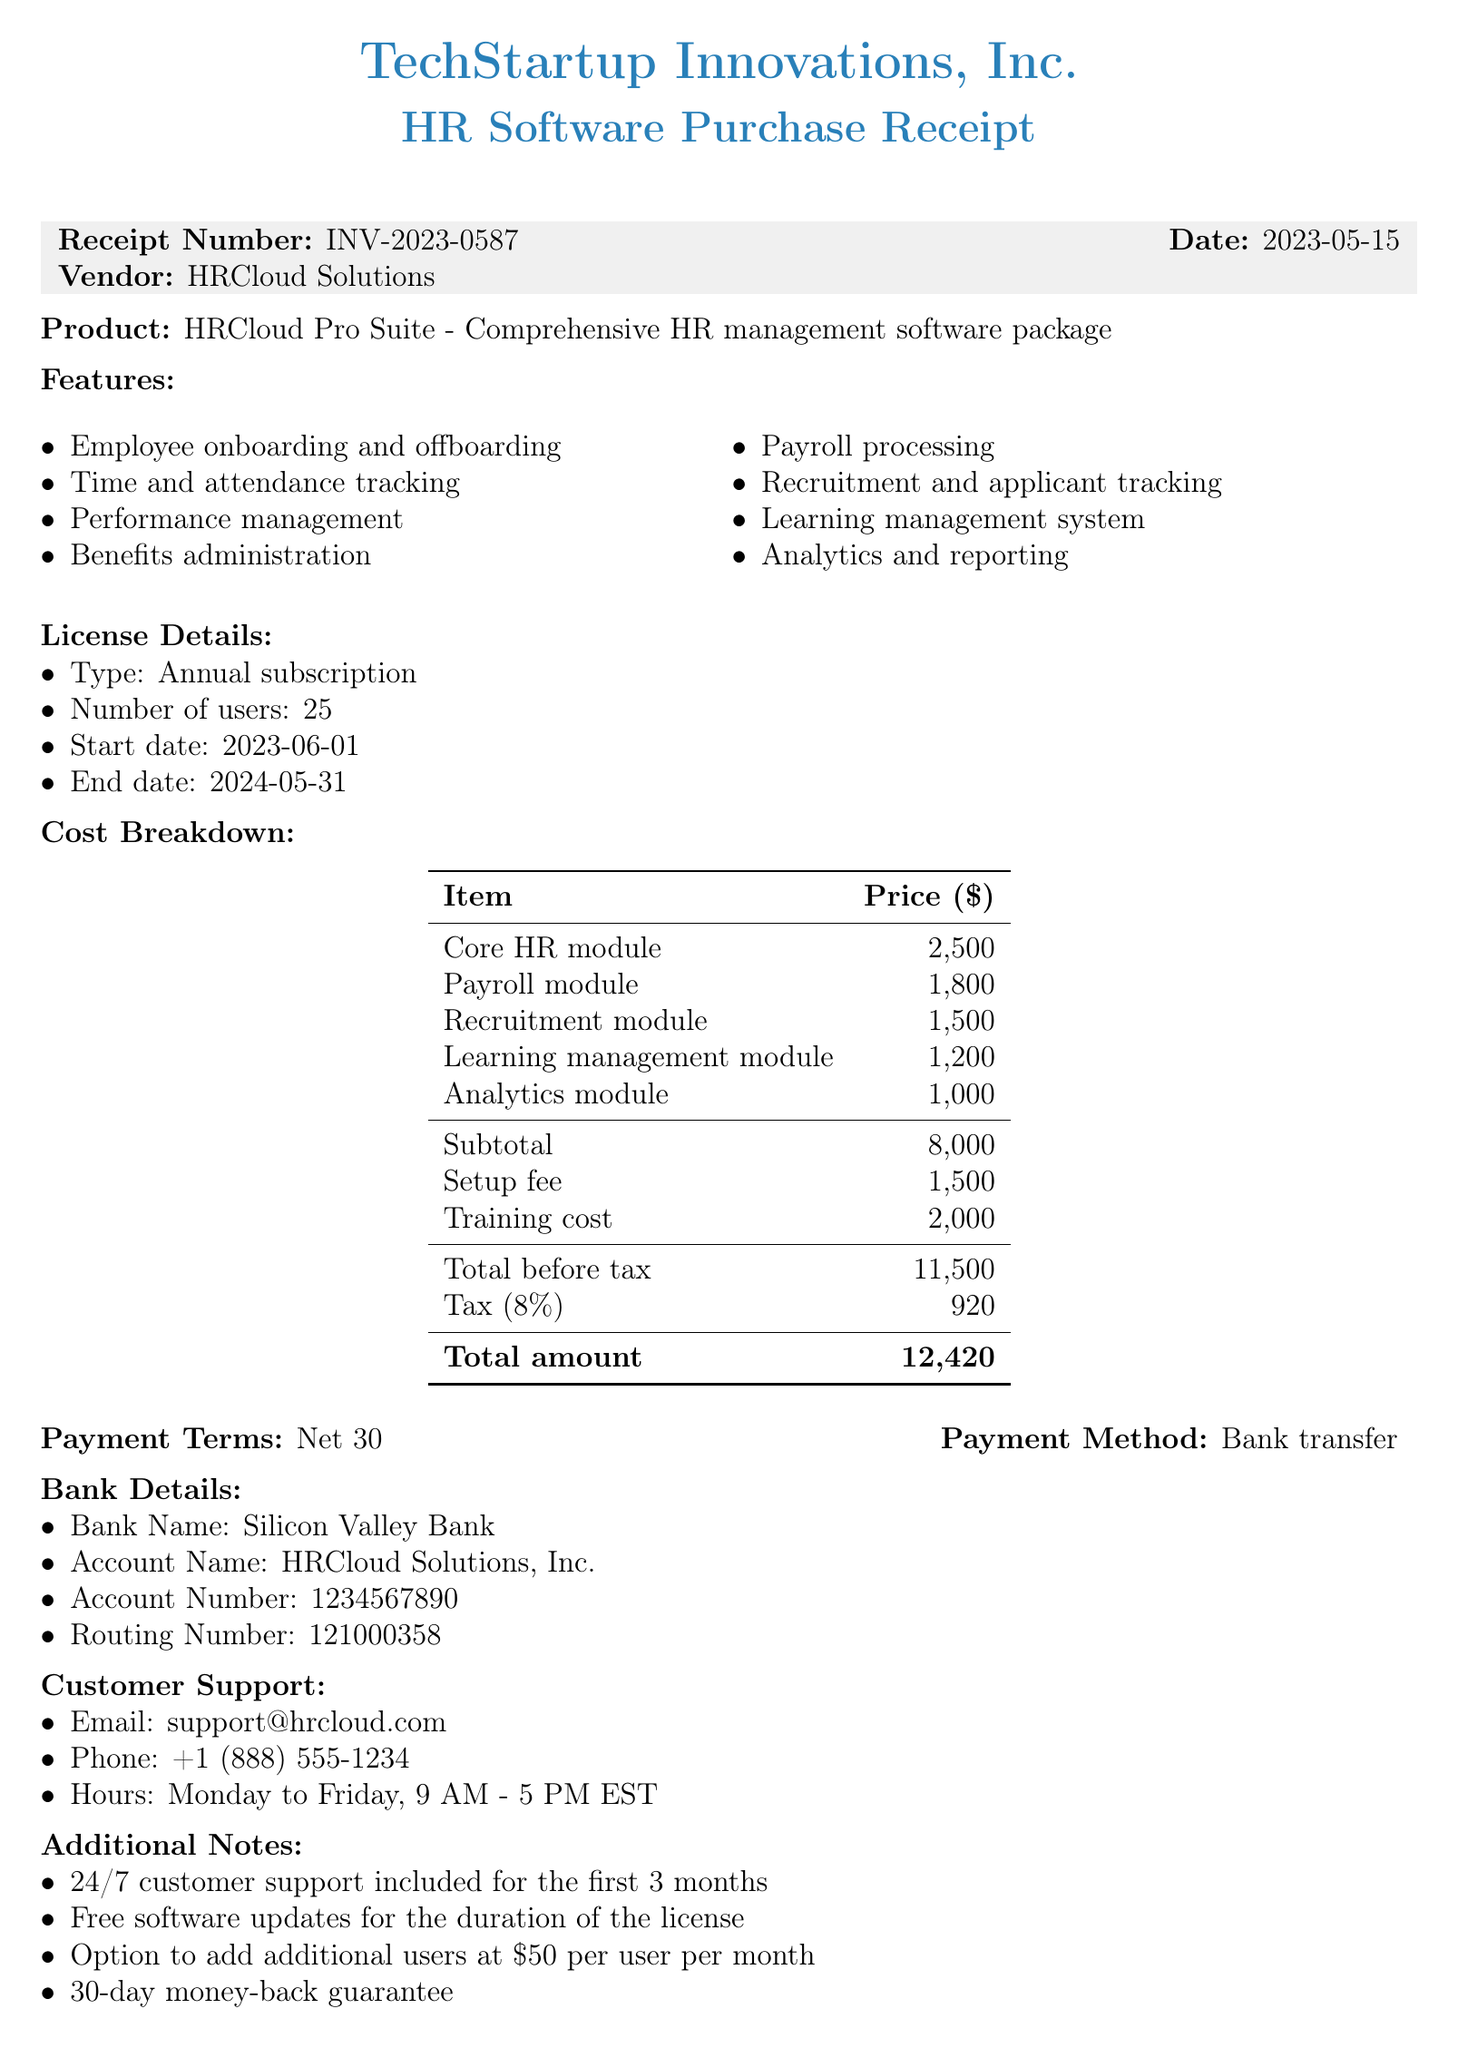What is the receipt number? The receipt number is a unique identifier for the transaction document.
Answer: INV-2023-0587 What is the total amount due? The total amount due is the final charge including tax.
Answer: 12420 What is the start date of the license? The start date indicates when the license for the software begins.
Answer: 2023-06-01 How many users can the software license accommodate? This number indicates the limit on users allowed under this subscription.
Answer: 25 What is the training cost? The training cost is an additional expense associated with the software purchase.
Answer: 2000 What is the tax rate applied? The tax rate is the percentage used to calculate tax on the subtotal.
Answer: 0.08 What is the payment term specified? The payment term outlines the time frame within which payment is expected.
Answer: Net 30 What modules are included in the cost breakdown? These are the specific components of the software that are itemized in the costs.
Answer: Core HR module, Payroll module, Recruitment module, Learning management module, Analytics module What is included in the additional notes? This section contains important conditions and offerings related to the purchased software.
Answer: 24/7 customer support included for the first 3 months, Free software updates for the duration of the license, Option to add additional users at $50 per user per month, 30-day money-back guarantee 